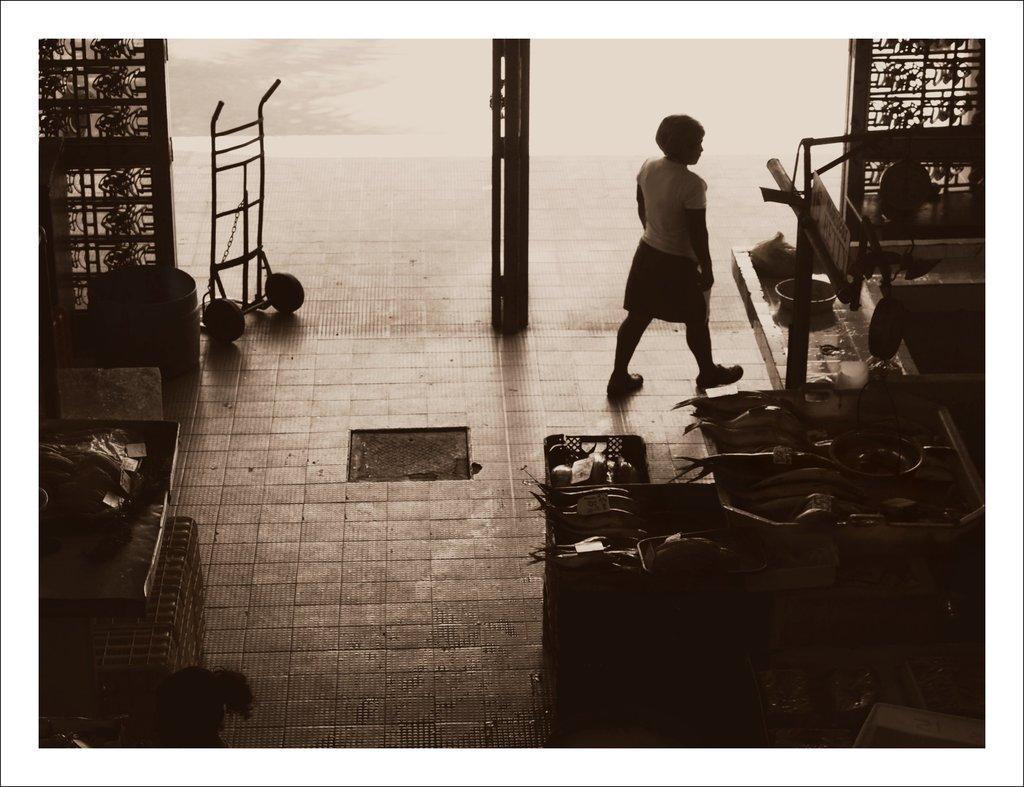Describe this image in one or two sentences. This is an edited image. There is a person in the middle. She is walking. There are tables and chairs in the middle. 